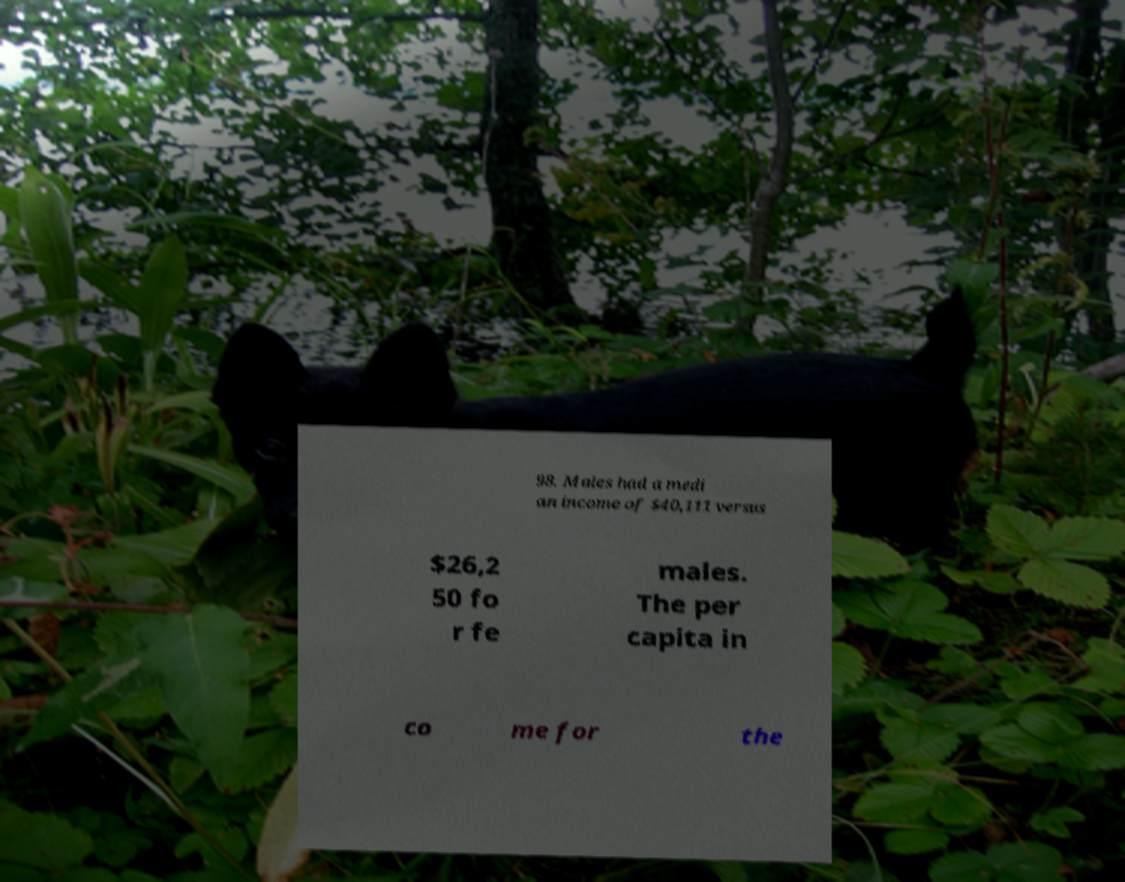Could you assist in decoding the text presented in this image and type it out clearly? 98. Males had a medi an income of $40,111 versus $26,2 50 fo r fe males. The per capita in co me for the 